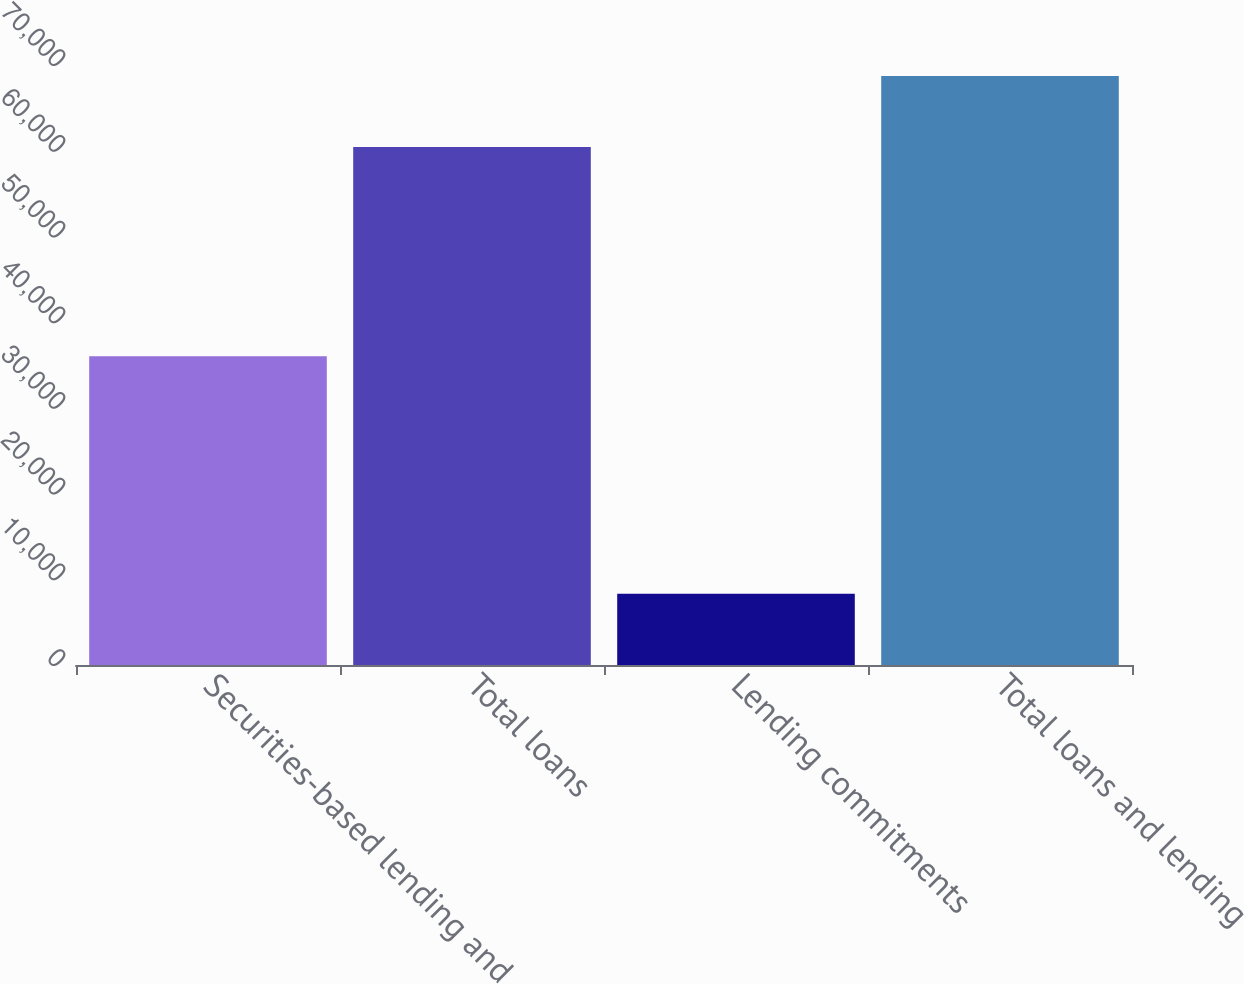Convert chart to OTSL. <chart><loc_0><loc_0><loc_500><loc_500><bar_chart><fcel>Securities-based lending and<fcel>Total loans<fcel>Lending commitments<fcel>Total loans and lending<nl><fcel>36013<fcel>60427<fcel>8299<fcel>68726<nl></chart> 